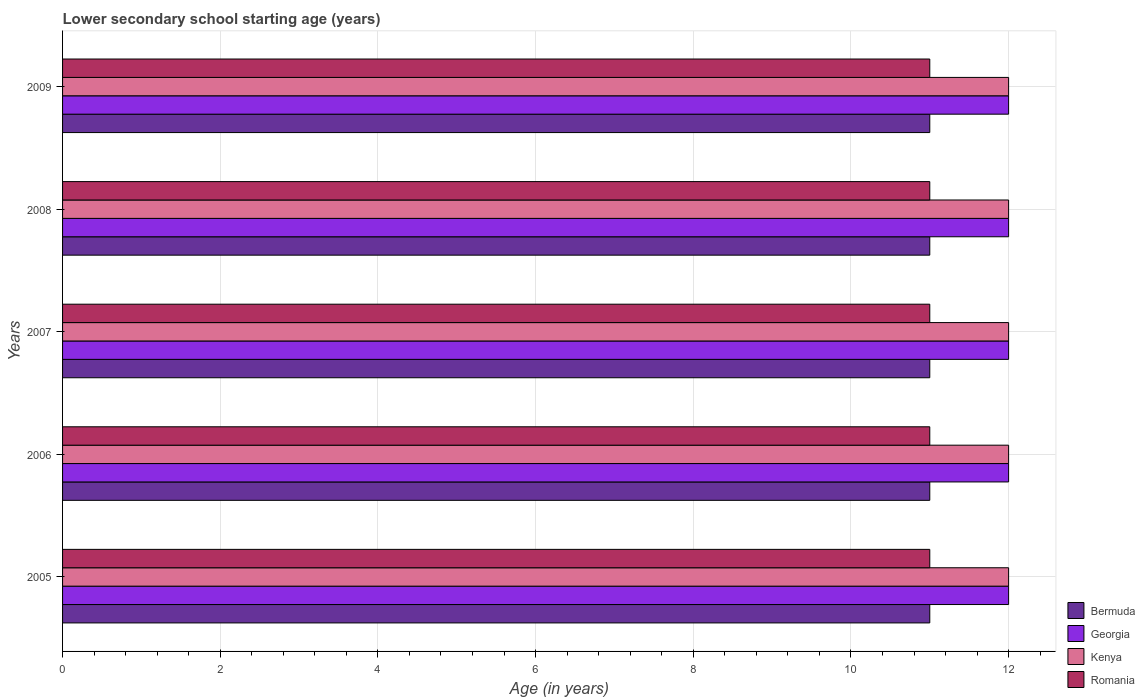How many groups of bars are there?
Provide a short and direct response. 5. Are the number of bars per tick equal to the number of legend labels?
Make the answer very short. Yes. How many bars are there on the 1st tick from the top?
Provide a succinct answer. 4. How many bars are there on the 3rd tick from the bottom?
Give a very brief answer. 4. In how many cases, is the number of bars for a given year not equal to the number of legend labels?
Give a very brief answer. 0. What is the lower secondary school starting age of children in Georgia in 2006?
Provide a succinct answer. 12. Across all years, what is the minimum lower secondary school starting age of children in Romania?
Offer a terse response. 11. What is the total lower secondary school starting age of children in Bermuda in the graph?
Your response must be concise. 55. What is the difference between the lower secondary school starting age of children in Bermuda in 2005 and that in 2006?
Provide a short and direct response. 0. What is the difference between the lower secondary school starting age of children in Bermuda in 2006 and the lower secondary school starting age of children in Georgia in 2008?
Keep it short and to the point. -1. What is the average lower secondary school starting age of children in Romania per year?
Offer a very short reply. 11. In the year 2006, what is the difference between the lower secondary school starting age of children in Georgia and lower secondary school starting age of children in Romania?
Your answer should be compact. 1. What is the ratio of the lower secondary school starting age of children in Romania in 2006 to that in 2009?
Your answer should be very brief. 1. Is the lower secondary school starting age of children in Kenya in 2006 less than that in 2008?
Make the answer very short. No. Is the difference between the lower secondary school starting age of children in Georgia in 2005 and 2008 greater than the difference between the lower secondary school starting age of children in Romania in 2005 and 2008?
Make the answer very short. No. What is the difference between the highest and the lowest lower secondary school starting age of children in Bermuda?
Provide a short and direct response. 0. In how many years, is the lower secondary school starting age of children in Kenya greater than the average lower secondary school starting age of children in Kenya taken over all years?
Your response must be concise. 0. Is the sum of the lower secondary school starting age of children in Romania in 2005 and 2009 greater than the maximum lower secondary school starting age of children in Bermuda across all years?
Your answer should be compact. Yes. Is it the case that in every year, the sum of the lower secondary school starting age of children in Georgia and lower secondary school starting age of children in Kenya is greater than the sum of lower secondary school starting age of children in Romania and lower secondary school starting age of children in Bermuda?
Provide a succinct answer. Yes. What does the 1st bar from the top in 2009 represents?
Make the answer very short. Romania. What does the 1st bar from the bottom in 2006 represents?
Give a very brief answer. Bermuda. Are the values on the major ticks of X-axis written in scientific E-notation?
Ensure brevity in your answer.  No. Does the graph contain any zero values?
Make the answer very short. No. How many legend labels are there?
Provide a short and direct response. 4. What is the title of the graph?
Offer a very short reply. Lower secondary school starting age (years). Does "Brazil" appear as one of the legend labels in the graph?
Provide a succinct answer. No. What is the label or title of the X-axis?
Offer a very short reply. Age (in years). What is the Age (in years) of Georgia in 2005?
Make the answer very short. 12. What is the Age (in years) of Romania in 2005?
Your answer should be compact. 11. What is the Age (in years) of Bermuda in 2006?
Ensure brevity in your answer.  11. What is the Age (in years) in Kenya in 2006?
Ensure brevity in your answer.  12. What is the Age (in years) of Romania in 2006?
Your answer should be compact. 11. What is the Age (in years) of Kenya in 2007?
Provide a succinct answer. 12. What is the Age (in years) of Romania in 2007?
Your answer should be compact. 11. What is the Age (in years) in Georgia in 2008?
Offer a very short reply. 12. What is the Age (in years) of Kenya in 2008?
Make the answer very short. 12. What is the Age (in years) of Georgia in 2009?
Your answer should be compact. 12. What is the Age (in years) of Kenya in 2009?
Offer a very short reply. 12. Across all years, what is the maximum Age (in years) in Georgia?
Keep it short and to the point. 12. What is the total Age (in years) in Bermuda in the graph?
Ensure brevity in your answer.  55. What is the total Age (in years) in Georgia in the graph?
Keep it short and to the point. 60. What is the total Age (in years) in Kenya in the graph?
Ensure brevity in your answer.  60. What is the difference between the Age (in years) in Georgia in 2005 and that in 2006?
Offer a very short reply. 0. What is the difference between the Age (in years) of Romania in 2005 and that in 2006?
Provide a short and direct response. 0. What is the difference between the Age (in years) in Georgia in 2005 and that in 2007?
Make the answer very short. 0. What is the difference between the Age (in years) in Kenya in 2005 and that in 2007?
Give a very brief answer. 0. What is the difference between the Age (in years) of Georgia in 2005 and that in 2008?
Your response must be concise. 0. What is the difference between the Age (in years) in Bermuda in 2005 and that in 2009?
Offer a very short reply. 0. What is the difference between the Age (in years) in Bermuda in 2006 and that in 2007?
Your answer should be compact. 0. What is the difference between the Age (in years) of Georgia in 2006 and that in 2007?
Provide a short and direct response. 0. What is the difference between the Age (in years) in Romania in 2006 and that in 2007?
Provide a short and direct response. 0. What is the difference between the Age (in years) in Bermuda in 2006 and that in 2008?
Provide a short and direct response. 0. What is the difference between the Age (in years) of Georgia in 2006 and that in 2008?
Provide a succinct answer. 0. What is the difference between the Age (in years) of Kenya in 2006 and that in 2009?
Make the answer very short. 0. What is the difference between the Age (in years) of Romania in 2006 and that in 2009?
Keep it short and to the point. 0. What is the difference between the Age (in years) of Bermuda in 2007 and that in 2008?
Provide a succinct answer. 0. What is the difference between the Age (in years) in Georgia in 2007 and that in 2008?
Give a very brief answer. 0. What is the difference between the Age (in years) of Georgia in 2007 and that in 2009?
Your answer should be compact. 0. What is the difference between the Age (in years) in Bermuda in 2008 and that in 2009?
Provide a short and direct response. 0. What is the difference between the Age (in years) in Georgia in 2008 and that in 2009?
Your response must be concise. 0. What is the difference between the Age (in years) in Romania in 2008 and that in 2009?
Your answer should be very brief. 0. What is the difference between the Age (in years) in Bermuda in 2005 and the Age (in years) in Georgia in 2006?
Provide a succinct answer. -1. What is the difference between the Age (in years) in Georgia in 2005 and the Age (in years) in Romania in 2006?
Provide a short and direct response. 1. What is the difference between the Age (in years) of Bermuda in 2005 and the Age (in years) of Kenya in 2007?
Your answer should be very brief. -1. What is the difference between the Age (in years) in Georgia in 2005 and the Age (in years) in Kenya in 2007?
Ensure brevity in your answer.  0. What is the difference between the Age (in years) of Georgia in 2005 and the Age (in years) of Romania in 2007?
Your response must be concise. 1. What is the difference between the Age (in years) of Bermuda in 2005 and the Age (in years) of Georgia in 2008?
Provide a succinct answer. -1. What is the difference between the Age (in years) in Bermuda in 2005 and the Age (in years) in Kenya in 2008?
Offer a very short reply. -1. What is the difference between the Age (in years) of Bermuda in 2005 and the Age (in years) of Romania in 2008?
Offer a terse response. 0. What is the difference between the Age (in years) of Georgia in 2005 and the Age (in years) of Kenya in 2008?
Provide a short and direct response. 0. What is the difference between the Age (in years) of Bermuda in 2005 and the Age (in years) of Georgia in 2009?
Make the answer very short. -1. What is the difference between the Age (in years) in Bermuda in 2005 and the Age (in years) in Kenya in 2009?
Offer a terse response. -1. What is the difference between the Age (in years) in Georgia in 2005 and the Age (in years) in Romania in 2009?
Your answer should be very brief. 1. What is the difference between the Age (in years) in Bermuda in 2006 and the Age (in years) in Georgia in 2007?
Provide a short and direct response. -1. What is the difference between the Age (in years) in Bermuda in 2006 and the Age (in years) in Romania in 2007?
Give a very brief answer. 0. What is the difference between the Age (in years) in Georgia in 2006 and the Age (in years) in Romania in 2007?
Provide a succinct answer. 1. What is the difference between the Age (in years) in Kenya in 2006 and the Age (in years) in Romania in 2007?
Provide a succinct answer. 1. What is the difference between the Age (in years) in Georgia in 2006 and the Age (in years) in Romania in 2008?
Offer a terse response. 1. What is the difference between the Age (in years) of Kenya in 2006 and the Age (in years) of Romania in 2008?
Give a very brief answer. 1. What is the difference between the Age (in years) in Kenya in 2006 and the Age (in years) in Romania in 2009?
Offer a terse response. 1. What is the difference between the Age (in years) in Bermuda in 2007 and the Age (in years) in Kenya in 2008?
Give a very brief answer. -1. What is the difference between the Age (in years) in Georgia in 2007 and the Age (in years) in Kenya in 2008?
Ensure brevity in your answer.  0. What is the difference between the Age (in years) in Kenya in 2007 and the Age (in years) in Romania in 2008?
Keep it short and to the point. 1. What is the difference between the Age (in years) of Bermuda in 2007 and the Age (in years) of Georgia in 2009?
Make the answer very short. -1. What is the difference between the Age (in years) of Bermuda in 2007 and the Age (in years) of Romania in 2009?
Offer a terse response. 0. What is the difference between the Age (in years) in Bermuda in 2008 and the Age (in years) in Georgia in 2009?
Keep it short and to the point. -1. What is the difference between the Age (in years) in Bermuda in 2008 and the Age (in years) in Kenya in 2009?
Provide a succinct answer. -1. What is the difference between the Age (in years) of Bermuda in 2008 and the Age (in years) of Romania in 2009?
Make the answer very short. 0. What is the difference between the Age (in years) of Kenya in 2008 and the Age (in years) of Romania in 2009?
Your answer should be compact. 1. What is the average Age (in years) in Georgia per year?
Provide a short and direct response. 12. What is the average Age (in years) in Kenya per year?
Offer a very short reply. 12. In the year 2005, what is the difference between the Age (in years) in Bermuda and Age (in years) in Kenya?
Your answer should be very brief. -1. In the year 2005, what is the difference between the Age (in years) in Kenya and Age (in years) in Romania?
Offer a terse response. 1. In the year 2006, what is the difference between the Age (in years) in Bermuda and Age (in years) in Romania?
Offer a very short reply. 0. In the year 2006, what is the difference between the Age (in years) of Georgia and Age (in years) of Kenya?
Make the answer very short. 0. In the year 2007, what is the difference between the Age (in years) of Bermuda and Age (in years) of Georgia?
Ensure brevity in your answer.  -1. In the year 2007, what is the difference between the Age (in years) in Kenya and Age (in years) in Romania?
Your answer should be compact. 1. In the year 2008, what is the difference between the Age (in years) of Bermuda and Age (in years) of Georgia?
Provide a succinct answer. -1. In the year 2008, what is the difference between the Age (in years) in Bermuda and Age (in years) in Kenya?
Offer a terse response. -1. In the year 2008, what is the difference between the Age (in years) in Georgia and Age (in years) in Kenya?
Give a very brief answer. 0. In the year 2008, what is the difference between the Age (in years) in Georgia and Age (in years) in Romania?
Your response must be concise. 1. In the year 2008, what is the difference between the Age (in years) of Kenya and Age (in years) of Romania?
Provide a succinct answer. 1. In the year 2009, what is the difference between the Age (in years) in Bermuda and Age (in years) in Georgia?
Offer a very short reply. -1. In the year 2009, what is the difference between the Age (in years) of Bermuda and Age (in years) of Romania?
Your answer should be very brief. 0. In the year 2009, what is the difference between the Age (in years) in Georgia and Age (in years) in Kenya?
Keep it short and to the point. 0. In the year 2009, what is the difference between the Age (in years) of Georgia and Age (in years) of Romania?
Ensure brevity in your answer.  1. In the year 2009, what is the difference between the Age (in years) of Kenya and Age (in years) of Romania?
Give a very brief answer. 1. What is the ratio of the Age (in years) of Bermuda in 2005 to that in 2006?
Provide a succinct answer. 1. What is the ratio of the Age (in years) of Georgia in 2005 to that in 2006?
Your response must be concise. 1. What is the ratio of the Age (in years) of Romania in 2005 to that in 2006?
Make the answer very short. 1. What is the ratio of the Age (in years) of Romania in 2005 to that in 2007?
Provide a succinct answer. 1. What is the ratio of the Age (in years) of Georgia in 2005 to that in 2008?
Make the answer very short. 1. What is the ratio of the Age (in years) in Romania in 2005 to that in 2008?
Make the answer very short. 1. What is the ratio of the Age (in years) of Bermuda in 2005 to that in 2009?
Your answer should be compact. 1. What is the ratio of the Age (in years) of Romania in 2005 to that in 2009?
Your response must be concise. 1. What is the ratio of the Age (in years) in Bermuda in 2006 to that in 2008?
Offer a very short reply. 1. What is the ratio of the Age (in years) in Georgia in 2006 to that in 2008?
Make the answer very short. 1. What is the ratio of the Age (in years) in Kenya in 2006 to that in 2008?
Give a very brief answer. 1. What is the ratio of the Age (in years) of Bermuda in 2006 to that in 2009?
Offer a terse response. 1. What is the ratio of the Age (in years) of Georgia in 2006 to that in 2009?
Provide a short and direct response. 1. What is the ratio of the Age (in years) in Kenya in 2006 to that in 2009?
Offer a very short reply. 1. What is the ratio of the Age (in years) in Romania in 2006 to that in 2009?
Offer a terse response. 1. What is the ratio of the Age (in years) in Georgia in 2007 to that in 2008?
Keep it short and to the point. 1. What is the ratio of the Age (in years) of Romania in 2007 to that in 2008?
Your answer should be very brief. 1. What is the ratio of the Age (in years) in Georgia in 2007 to that in 2009?
Offer a terse response. 1. What is the ratio of the Age (in years) in Kenya in 2007 to that in 2009?
Ensure brevity in your answer.  1. What is the ratio of the Age (in years) of Romania in 2007 to that in 2009?
Offer a very short reply. 1. What is the ratio of the Age (in years) in Georgia in 2008 to that in 2009?
Offer a very short reply. 1. What is the ratio of the Age (in years) in Kenya in 2008 to that in 2009?
Your answer should be very brief. 1. What is the difference between the highest and the second highest Age (in years) in Bermuda?
Ensure brevity in your answer.  0. What is the difference between the highest and the second highest Age (in years) of Kenya?
Make the answer very short. 0. What is the difference between the highest and the lowest Age (in years) of Georgia?
Give a very brief answer. 0. What is the difference between the highest and the lowest Age (in years) of Romania?
Your answer should be compact. 0. 